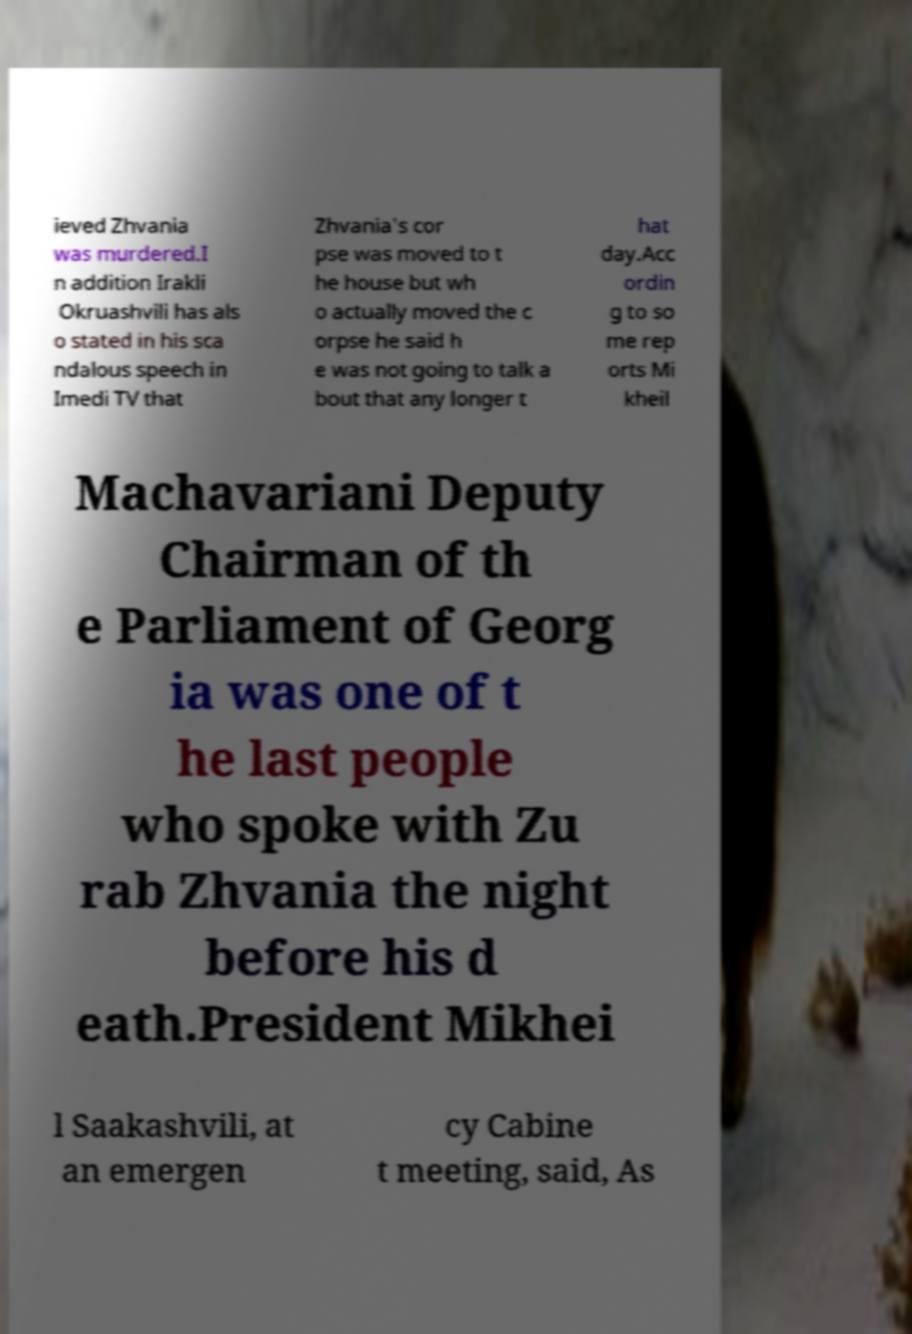Please identify and transcribe the text found in this image. ieved Zhvania was murdered.I n addition Irakli Okruashvili has als o stated in his sca ndalous speech in Imedi TV that Zhvania's cor pse was moved to t he house but wh o actually moved the c orpse he said h e was not going to talk a bout that any longer t hat day.Acc ordin g to so me rep orts Mi kheil Machavariani Deputy Chairman of th e Parliament of Georg ia was one of t he last people who spoke with Zu rab Zhvania the night before his d eath.President Mikhei l Saakashvili, at an emergen cy Cabine t meeting, said, As 